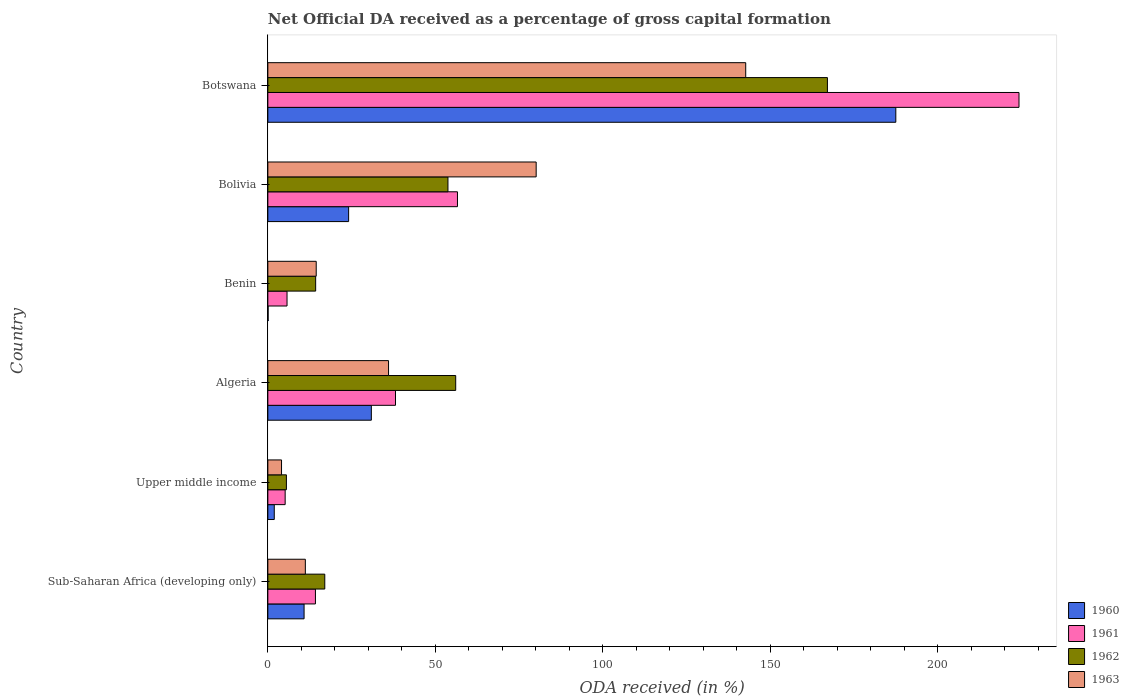How many bars are there on the 3rd tick from the top?
Make the answer very short. 4. How many bars are there on the 2nd tick from the bottom?
Make the answer very short. 4. What is the label of the 4th group of bars from the top?
Give a very brief answer. Algeria. What is the net ODA received in 1960 in Botswana?
Offer a terse response. 187.49. Across all countries, what is the maximum net ODA received in 1962?
Your response must be concise. 167.07. Across all countries, what is the minimum net ODA received in 1961?
Offer a very short reply. 5.17. In which country was the net ODA received in 1961 maximum?
Offer a terse response. Botswana. In which country was the net ODA received in 1960 minimum?
Your answer should be very brief. Benin. What is the total net ODA received in 1963 in the graph?
Provide a short and direct response. 288.55. What is the difference between the net ODA received in 1962 in Sub-Saharan Africa (developing only) and that in Upper middle income?
Provide a succinct answer. 11.45. What is the difference between the net ODA received in 1962 in Benin and the net ODA received in 1960 in Upper middle income?
Give a very brief answer. 12.36. What is the average net ODA received in 1962 per country?
Offer a very short reply. 52.29. What is the difference between the net ODA received in 1960 and net ODA received in 1963 in Sub-Saharan Africa (developing only)?
Ensure brevity in your answer.  -0.38. What is the ratio of the net ODA received in 1962 in Benin to that in Upper middle income?
Provide a short and direct response. 2.58. Is the difference between the net ODA received in 1960 in Algeria and Botswana greater than the difference between the net ODA received in 1963 in Algeria and Botswana?
Your answer should be very brief. No. What is the difference between the highest and the second highest net ODA received in 1963?
Provide a succinct answer. 62.56. What is the difference between the highest and the lowest net ODA received in 1963?
Provide a succinct answer. 138.59. In how many countries, is the net ODA received in 1960 greater than the average net ODA received in 1960 taken over all countries?
Keep it short and to the point. 1. Is the sum of the net ODA received in 1962 in Algeria and Benin greater than the maximum net ODA received in 1963 across all countries?
Make the answer very short. No. Is it the case that in every country, the sum of the net ODA received in 1962 and net ODA received in 1961 is greater than the sum of net ODA received in 1963 and net ODA received in 1960?
Offer a terse response. No. What does the 3rd bar from the bottom in Botswana represents?
Provide a short and direct response. 1962. How many bars are there?
Provide a short and direct response. 24. Are all the bars in the graph horizontal?
Make the answer very short. Yes. How many countries are there in the graph?
Give a very brief answer. 6. Does the graph contain any zero values?
Keep it short and to the point. No. Does the graph contain grids?
Offer a terse response. No. Where does the legend appear in the graph?
Give a very brief answer. Bottom right. How are the legend labels stacked?
Make the answer very short. Vertical. What is the title of the graph?
Offer a very short reply. Net Official DA received as a percentage of gross capital formation. What is the label or title of the X-axis?
Provide a short and direct response. ODA received (in %). What is the ODA received (in %) in 1960 in Sub-Saharan Africa (developing only)?
Give a very brief answer. 10.82. What is the ODA received (in %) in 1961 in Sub-Saharan Africa (developing only)?
Your answer should be compact. 14.21. What is the ODA received (in %) of 1962 in Sub-Saharan Africa (developing only)?
Your answer should be compact. 17. What is the ODA received (in %) in 1963 in Sub-Saharan Africa (developing only)?
Provide a succinct answer. 11.2. What is the ODA received (in %) of 1960 in Upper middle income?
Make the answer very short. 1.92. What is the ODA received (in %) in 1961 in Upper middle income?
Your answer should be very brief. 5.17. What is the ODA received (in %) of 1962 in Upper middle income?
Your answer should be very brief. 5.54. What is the ODA received (in %) in 1963 in Upper middle income?
Provide a succinct answer. 4.09. What is the ODA received (in %) of 1960 in Algeria?
Offer a very short reply. 30.9. What is the ODA received (in %) in 1961 in Algeria?
Provide a short and direct response. 38.11. What is the ODA received (in %) of 1962 in Algeria?
Your answer should be compact. 56.09. What is the ODA received (in %) in 1963 in Algeria?
Ensure brevity in your answer.  36.04. What is the ODA received (in %) of 1960 in Benin?
Your response must be concise. 0.08. What is the ODA received (in %) of 1961 in Benin?
Your response must be concise. 5.73. What is the ODA received (in %) in 1962 in Benin?
Provide a succinct answer. 14.28. What is the ODA received (in %) in 1963 in Benin?
Ensure brevity in your answer.  14.44. What is the ODA received (in %) of 1960 in Bolivia?
Keep it short and to the point. 24.12. What is the ODA received (in %) in 1961 in Bolivia?
Ensure brevity in your answer.  56.62. What is the ODA received (in %) in 1962 in Bolivia?
Provide a succinct answer. 53.77. What is the ODA received (in %) in 1963 in Bolivia?
Give a very brief answer. 80.11. What is the ODA received (in %) of 1960 in Botswana?
Your response must be concise. 187.49. What is the ODA received (in %) of 1961 in Botswana?
Your answer should be compact. 224.27. What is the ODA received (in %) in 1962 in Botswana?
Provide a succinct answer. 167.07. What is the ODA received (in %) of 1963 in Botswana?
Give a very brief answer. 142.68. Across all countries, what is the maximum ODA received (in %) of 1960?
Offer a terse response. 187.49. Across all countries, what is the maximum ODA received (in %) of 1961?
Offer a terse response. 224.27. Across all countries, what is the maximum ODA received (in %) of 1962?
Ensure brevity in your answer.  167.07. Across all countries, what is the maximum ODA received (in %) in 1963?
Ensure brevity in your answer.  142.68. Across all countries, what is the minimum ODA received (in %) of 1960?
Provide a succinct answer. 0.08. Across all countries, what is the minimum ODA received (in %) of 1961?
Give a very brief answer. 5.17. Across all countries, what is the minimum ODA received (in %) in 1962?
Ensure brevity in your answer.  5.54. Across all countries, what is the minimum ODA received (in %) in 1963?
Make the answer very short. 4.09. What is the total ODA received (in %) in 1960 in the graph?
Make the answer very short. 255.32. What is the total ODA received (in %) in 1961 in the graph?
Offer a very short reply. 344.1. What is the total ODA received (in %) of 1962 in the graph?
Your answer should be very brief. 313.75. What is the total ODA received (in %) in 1963 in the graph?
Offer a terse response. 288.55. What is the difference between the ODA received (in %) in 1960 in Sub-Saharan Africa (developing only) and that in Upper middle income?
Offer a very short reply. 8.9. What is the difference between the ODA received (in %) of 1961 in Sub-Saharan Africa (developing only) and that in Upper middle income?
Offer a terse response. 9.04. What is the difference between the ODA received (in %) in 1962 in Sub-Saharan Africa (developing only) and that in Upper middle income?
Your response must be concise. 11.45. What is the difference between the ODA received (in %) in 1963 in Sub-Saharan Africa (developing only) and that in Upper middle income?
Make the answer very short. 7.11. What is the difference between the ODA received (in %) in 1960 in Sub-Saharan Africa (developing only) and that in Algeria?
Offer a terse response. -20.09. What is the difference between the ODA received (in %) of 1961 in Sub-Saharan Africa (developing only) and that in Algeria?
Your answer should be very brief. -23.9. What is the difference between the ODA received (in %) of 1962 in Sub-Saharan Africa (developing only) and that in Algeria?
Offer a terse response. -39.09. What is the difference between the ODA received (in %) of 1963 in Sub-Saharan Africa (developing only) and that in Algeria?
Give a very brief answer. -24.84. What is the difference between the ODA received (in %) in 1960 in Sub-Saharan Africa (developing only) and that in Benin?
Make the answer very short. 10.74. What is the difference between the ODA received (in %) of 1961 in Sub-Saharan Africa (developing only) and that in Benin?
Offer a terse response. 8.48. What is the difference between the ODA received (in %) in 1962 in Sub-Saharan Africa (developing only) and that in Benin?
Offer a very short reply. 2.72. What is the difference between the ODA received (in %) of 1963 in Sub-Saharan Africa (developing only) and that in Benin?
Provide a short and direct response. -3.25. What is the difference between the ODA received (in %) in 1960 in Sub-Saharan Africa (developing only) and that in Bolivia?
Make the answer very short. -13.3. What is the difference between the ODA received (in %) of 1961 in Sub-Saharan Africa (developing only) and that in Bolivia?
Your answer should be very brief. -42.41. What is the difference between the ODA received (in %) of 1962 in Sub-Saharan Africa (developing only) and that in Bolivia?
Keep it short and to the point. -36.78. What is the difference between the ODA received (in %) in 1963 in Sub-Saharan Africa (developing only) and that in Bolivia?
Make the answer very short. -68.92. What is the difference between the ODA received (in %) in 1960 in Sub-Saharan Africa (developing only) and that in Botswana?
Give a very brief answer. -176.67. What is the difference between the ODA received (in %) of 1961 in Sub-Saharan Africa (developing only) and that in Botswana?
Give a very brief answer. -210.06. What is the difference between the ODA received (in %) of 1962 in Sub-Saharan Africa (developing only) and that in Botswana?
Your response must be concise. -150.07. What is the difference between the ODA received (in %) in 1963 in Sub-Saharan Africa (developing only) and that in Botswana?
Offer a terse response. -131.48. What is the difference between the ODA received (in %) in 1960 in Upper middle income and that in Algeria?
Your response must be concise. -28.99. What is the difference between the ODA received (in %) in 1961 in Upper middle income and that in Algeria?
Offer a very short reply. -32.94. What is the difference between the ODA received (in %) of 1962 in Upper middle income and that in Algeria?
Give a very brief answer. -50.54. What is the difference between the ODA received (in %) of 1963 in Upper middle income and that in Algeria?
Your answer should be compact. -31.95. What is the difference between the ODA received (in %) in 1960 in Upper middle income and that in Benin?
Provide a succinct answer. 1.84. What is the difference between the ODA received (in %) of 1961 in Upper middle income and that in Benin?
Provide a succinct answer. -0.56. What is the difference between the ODA received (in %) in 1962 in Upper middle income and that in Benin?
Your response must be concise. -8.73. What is the difference between the ODA received (in %) of 1963 in Upper middle income and that in Benin?
Keep it short and to the point. -10.35. What is the difference between the ODA received (in %) in 1960 in Upper middle income and that in Bolivia?
Ensure brevity in your answer.  -22.2. What is the difference between the ODA received (in %) of 1961 in Upper middle income and that in Bolivia?
Your answer should be very brief. -51.45. What is the difference between the ODA received (in %) of 1962 in Upper middle income and that in Bolivia?
Your answer should be very brief. -48.23. What is the difference between the ODA received (in %) in 1963 in Upper middle income and that in Bolivia?
Make the answer very short. -76.03. What is the difference between the ODA received (in %) of 1960 in Upper middle income and that in Botswana?
Offer a terse response. -185.57. What is the difference between the ODA received (in %) of 1961 in Upper middle income and that in Botswana?
Your response must be concise. -219.1. What is the difference between the ODA received (in %) in 1962 in Upper middle income and that in Botswana?
Offer a very short reply. -161.53. What is the difference between the ODA received (in %) in 1963 in Upper middle income and that in Botswana?
Your response must be concise. -138.59. What is the difference between the ODA received (in %) of 1960 in Algeria and that in Benin?
Keep it short and to the point. 30.82. What is the difference between the ODA received (in %) in 1961 in Algeria and that in Benin?
Offer a very short reply. 32.39. What is the difference between the ODA received (in %) in 1962 in Algeria and that in Benin?
Make the answer very short. 41.81. What is the difference between the ODA received (in %) of 1963 in Algeria and that in Benin?
Offer a very short reply. 21.6. What is the difference between the ODA received (in %) of 1960 in Algeria and that in Bolivia?
Your response must be concise. 6.78. What is the difference between the ODA received (in %) in 1961 in Algeria and that in Bolivia?
Offer a very short reply. -18.5. What is the difference between the ODA received (in %) in 1962 in Algeria and that in Bolivia?
Your answer should be very brief. 2.31. What is the difference between the ODA received (in %) of 1963 in Algeria and that in Bolivia?
Provide a succinct answer. -44.08. What is the difference between the ODA received (in %) of 1960 in Algeria and that in Botswana?
Offer a very short reply. -156.58. What is the difference between the ODA received (in %) of 1961 in Algeria and that in Botswana?
Your response must be concise. -186.15. What is the difference between the ODA received (in %) in 1962 in Algeria and that in Botswana?
Keep it short and to the point. -110.98. What is the difference between the ODA received (in %) in 1963 in Algeria and that in Botswana?
Keep it short and to the point. -106.64. What is the difference between the ODA received (in %) in 1960 in Benin and that in Bolivia?
Make the answer very short. -24.04. What is the difference between the ODA received (in %) of 1961 in Benin and that in Bolivia?
Keep it short and to the point. -50.89. What is the difference between the ODA received (in %) of 1962 in Benin and that in Bolivia?
Your answer should be compact. -39.5. What is the difference between the ODA received (in %) of 1963 in Benin and that in Bolivia?
Ensure brevity in your answer.  -65.67. What is the difference between the ODA received (in %) in 1960 in Benin and that in Botswana?
Offer a terse response. -187.41. What is the difference between the ODA received (in %) of 1961 in Benin and that in Botswana?
Provide a succinct answer. -218.54. What is the difference between the ODA received (in %) in 1962 in Benin and that in Botswana?
Make the answer very short. -152.79. What is the difference between the ODA received (in %) of 1963 in Benin and that in Botswana?
Your answer should be very brief. -128.24. What is the difference between the ODA received (in %) in 1960 in Bolivia and that in Botswana?
Your answer should be compact. -163.37. What is the difference between the ODA received (in %) in 1961 in Bolivia and that in Botswana?
Keep it short and to the point. -167.65. What is the difference between the ODA received (in %) of 1962 in Bolivia and that in Botswana?
Your response must be concise. -113.3. What is the difference between the ODA received (in %) of 1963 in Bolivia and that in Botswana?
Provide a short and direct response. -62.56. What is the difference between the ODA received (in %) of 1960 in Sub-Saharan Africa (developing only) and the ODA received (in %) of 1961 in Upper middle income?
Ensure brevity in your answer.  5.65. What is the difference between the ODA received (in %) of 1960 in Sub-Saharan Africa (developing only) and the ODA received (in %) of 1962 in Upper middle income?
Offer a very short reply. 5.27. What is the difference between the ODA received (in %) in 1960 in Sub-Saharan Africa (developing only) and the ODA received (in %) in 1963 in Upper middle income?
Ensure brevity in your answer.  6.73. What is the difference between the ODA received (in %) of 1961 in Sub-Saharan Africa (developing only) and the ODA received (in %) of 1962 in Upper middle income?
Your answer should be compact. 8.67. What is the difference between the ODA received (in %) in 1961 in Sub-Saharan Africa (developing only) and the ODA received (in %) in 1963 in Upper middle income?
Provide a succinct answer. 10.12. What is the difference between the ODA received (in %) in 1962 in Sub-Saharan Africa (developing only) and the ODA received (in %) in 1963 in Upper middle income?
Give a very brief answer. 12.91. What is the difference between the ODA received (in %) in 1960 in Sub-Saharan Africa (developing only) and the ODA received (in %) in 1961 in Algeria?
Offer a very short reply. -27.3. What is the difference between the ODA received (in %) in 1960 in Sub-Saharan Africa (developing only) and the ODA received (in %) in 1962 in Algeria?
Make the answer very short. -45.27. What is the difference between the ODA received (in %) of 1960 in Sub-Saharan Africa (developing only) and the ODA received (in %) of 1963 in Algeria?
Your answer should be compact. -25.22. What is the difference between the ODA received (in %) in 1961 in Sub-Saharan Africa (developing only) and the ODA received (in %) in 1962 in Algeria?
Ensure brevity in your answer.  -41.88. What is the difference between the ODA received (in %) in 1961 in Sub-Saharan Africa (developing only) and the ODA received (in %) in 1963 in Algeria?
Your answer should be very brief. -21.83. What is the difference between the ODA received (in %) of 1962 in Sub-Saharan Africa (developing only) and the ODA received (in %) of 1963 in Algeria?
Provide a succinct answer. -19.04. What is the difference between the ODA received (in %) in 1960 in Sub-Saharan Africa (developing only) and the ODA received (in %) in 1961 in Benin?
Keep it short and to the point. 5.09. What is the difference between the ODA received (in %) in 1960 in Sub-Saharan Africa (developing only) and the ODA received (in %) in 1962 in Benin?
Offer a very short reply. -3.46. What is the difference between the ODA received (in %) in 1960 in Sub-Saharan Africa (developing only) and the ODA received (in %) in 1963 in Benin?
Provide a succinct answer. -3.62. What is the difference between the ODA received (in %) in 1961 in Sub-Saharan Africa (developing only) and the ODA received (in %) in 1962 in Benin?
Offer a very short reply. -0.07. What is the difference between the ODA received (in %) of 1961 in Sub-Saharan Africa (developing only) and the ODA received (in %) of 1963 in Benin?
Give a very brief answer. -0.23. What is the difference between the ODA received (in %) in 1962 in Sub-Saharan Africa (developing only) and the ODA received (in %) in 1963 in Benin?
Give a very brief answer. 2.56. What is the difference between the ODA received (in %) of 1960 in Sub-Saharan Africa (developing only) and the ODA received (in %) of 1961 in Bolivia?
Ensure brevity in your answer.  -45.8. What is the difference between the ODA received (in %) in 1960 in Sub-Saharan Africa (developing only) and the ODA received (in %) in 1962 in Bolivia?
Offer a very short reply. -42.96. What is the difference between the ODA received (in %) of 1960 in Sub-Saharan Africa (developing only) and the ODA received (in %) of 1963 in Bolivia?
Ensure brevity in your answer.  -69.3. What is the difference between the ODA received (in %) of 1961 in Sub-Saharan Africa (developing only) and the ODA received (in %) of 1962 in Bolivia?
Provide a short and direct response. -39.56. What is the difference between the ODA received (in %) in 1961 in Sub-Saharan Africa (developing only) and the ODA received (in %) in 1963 in Bolivia?
Provide a short and direct response. -65.91. What is the difference between the ODA received (in %) in 1962 in Sub-Saharan Africa (developing only) and the ODA received (in %) in 1963 in Bolivia?
Make the answer very short. -63.12. What is the difference between the ODA received (in %) of 1960 in Sub-Saharan Africa (developing only) and the ODA received (in %) of 1961 in Botswana?
Offer a terse response. -213.45. What is the difference between the ODA received (in %) of 1960 in Sub-Saharan Africa (developing only) and the ODA received (in %) of 1962 in Botswana?
Your answer should be compact. -156.25. What is the difference between the ODA received (in %) of 1960 in Sub-Saharan Africa (developing only) and the ODA received (in %) of 1963 in Botswana?
Keep it short and to the point. -131.86. What is the difference between the ODA received (in %) in 1961 in Sub-Saharan Africa (developing only) and the ODA received (in %) in 1962 in Botswana?
Keep it short and to the point. -152.86. What is the difference between the ODA received (in %) of 1961 in Sub-Saharan Africa (developing only) and the ODA received (in %) of 1963 in Botswana?
Offer a very short reply. -128.47. What is the difference between the ODA received (in %) of 1962 in Sub-Saharan Africa (developing only) and the ODA received (in %) of 1963 in Botswana?
Offer a terse response. -125.68. What is the difference between the ODA received (in %) of 1960 in Upper middle income and the ODA received (in %) of 1961 in Algeria?
Give a very brief answer. -36.2. What is the difference between the ODA received (in %) of 1960 in Upper middle income and the ODA received (in %) of 1962 in Algeria?
Provide a succinct answer. -54.17. What is the difference between the ODA received (in %) in 1960 in Upper middle income and the ODA received (in %) in 1963 in Algeria?
Offer a very short reply. -34.12. What is the difference between the ODA received (in %) of 1961 in Upper middle income and the ODA received (in %) of 1962 in Algeria?
Make the answer very short. -50.92. What is the difference between the ODA received (in %) of 1961 in Upper middle income and the ODA received (in %) of 1963 in Algeria?
Ensure brevity in your answer.  -30.87. What is the difference between the ODA received (in %) in 1962 in Upper middle income and the ODA received (in %) in 1963 in Algeria?
Ensure brevity in your answer.  -30.49. What is the difference between the ODA received (in %) in 1960 in Upper middle income and the ODA received (in %) in 1961 in Benin?
Keep it short and to the point. -3.81. What is the difference between the ODA received (in %) of 1960 in Upper middle income and the ODA received (in %) of 1962 in Benin?
Your response must be concise. -12.36. What is the difference between the ODA received (in %) of 1960 in Upper middle income and the ODA received (in %) of 1963 in Benin?
Keep it short and to the point. -12.53. What is the difference between the ODA received (in %) in 1961 in Upper middle income and the ODA received (in %) in 1962 in Benin?
Provide a succinct answer. -9.11. What is the difference between the ODA received (in %) of 1961 in Upper middle income and the ODA received (in %) of 1963 in Benin?
Your response must be concise. -9.27. What is the difference between the ODA received (in %) in 1962 in Upper middle income and the ODA received (in %) in 1963 in Benin?
Give a very brief answer. -8.9. What is the difference between the ODA received (in %) of 1960 in Upper middle income and the ODA received (in %) of 1961 in Bolivia?
Provide a short and direct response. -54.7. What is the difference between the ODA received (in %) of 1960 in Upper middle income and the ODA received (in %) of 1962 in Bolivia?
Provide a succinct answer. -51.86. What is the difference between the ODA received (in %) in 1960 in Upper middle income and the ODA received (in %) in 1963 in Bolivia?
Give a very brief answer. -78.2. What is the difference between the ODA received (in %) in 1961 in Upper middle income and the ODA received (in %) in 1962 in Bolivia?
Offer a terse response. -48.6. What is the difference between the ODA received (in %) in 1961 in Upper middle income and the ODA received (in %) in 1963 in Bolivia?
Provide a succinct answer. -74.94. What is the difference between the ODA received (in %) in 1962 in Upper middle income and the ODA received (in %) in 1963 in Bolivia?
Your answer should be very brief. -74.57. What is the difference between the ODA received (in %) of 1960 in Upper middle income and the ODA received (in %) of 1961 in Botswana?
Ensure brevity in your answer.  -222.35. What is the difference between the ODA received (in %) of 1960 in Upper middle income and the ODA received (in %) of 1962 in Botswana?
Your response must be concise. -165.15. What is the difference between the ODA received (in %) in 1960 in Upper middle income and the ODA received (in %) in 1963 in Botswana?
Give a very brief answer. -140.76. What is the difference between the ODA received (in %) of 1961 in Upper middle income and the ODA received (in %) of 1962 in Botswana?
Provide a short and direct response. -161.9. What is the difference between the ODA received (in %) of 1961 in Upper middle income and the ODA received (in %) of 1963 in Botswana?
Your answer should be compact. -137.51. What is the difference between the ODA received (in %) of 1962 in Upper middle income and the ODA received (in %) of 1963 in Botswana?
Ensure brevity in your answer.  -137.13. What is the difference between the ODA received (in %) in 1960 in Algeria and the ODA received (in %) in 1961 in Benin?
Provide a short and direct response. 25.17. What is the difference between the ODA received (in %) in 1960 in Algeria and the ODA received (in %) in 1962 in Benin?
Provide a short and direct response. 16.62. What is the difference between the ODA received (in %) of 1960 in Algeria and the ODA received (in %) of 1963 in Benin?
Ensure brevity in your answer.  16.46. What is the difference between the ODA received (in %) in 1961 in Algeria and the ODA received (in %) in 1962 in Benin?
Your answer should be compact. 23.84. What is the difference between the ODA received (in %) in 1961 in Algeria and the ODA received (in %) in 1963 in Benin?
Provide a short and direct response. 23.67. What is the difference between the ODA received (in %) in 1962 in Algeria and the ODA received (in %) in 1963 in Benin?
Your response must be concise. 41.65. What is the difference between the ODA received (in %) of 1960 in Algeria and the ODA received (in %) of 1961 in Bolivia?
Offer a very short reply. -25.71. What is the difference between the ODA received (in %) of 1960 in Algeria and the ODA received (in %) of 1962 in Bolivia?
Give a very brief answer. -22.87. What is the difference between the ODA received (in %) of 1960 in Algeria and the ODA received (in %) of 1963 in Bolivia?
Your answer should be very brief. -49.21. What is the difference between the ODA received (in %) of 1961 in Algeria and the ODA received (in %) of 1962 in Bolivia?
Your response must be concise. -15.66. What is the difference between the ODA received (in %) of 1961 in Algeria and the ODA received (in %) of 1963 in Bolivia?
Your answer should be very brief. -42. What is the difference between the ODA received (in %) of 1962 in Algeria and the ODA received (in %) of 1963 in Bolivia?
Ensure brevity in your answer.  -24.03. What is the difference between the ODA received (in %) of 1960 in Algeria and the ODA received (in %) of 1961 in Botswana?
Offer a very short reply. -193.36. What is the difference between the ODA received (in %) of 1960 in Algeria and the ODA received (in %) of 1962 in Botswana?
Your answer should be very brief. -136.17. What is the difference between the ODA received (in %) in 1960 in Algeria and the ODA received (in %) in 1963 in Botswana?
Your response must be concise. -111.78. What is the difference between the ODA received (in %) of 1961 in Algeria and the ODA received (in %) of 1962 in Botswana?
Your answer should be very brief. -128.96. What is the difference between the ODA received (in %) of 1961 in Algeria and the ODA received (in %) of 1963 in Botswana?
Ensure brevity in your answer.  -104.56. What is the difference between the ODA received (in %) of 1962 in Algeria and the ODA received (in %) of 1963 in Botswana?
Keep it short and to the point. -86.59. What is the difference between the ODA received (in %) of 1960 in Benin and the ODA received (in %) of 1961 in Bolivia?
Your answer should be very brief. -56.54. What is the difference between the ODA received (in %) of 1960 in Benin and the ODA received (in %) of 1962 in Bolivia?
Give a very brief answer. -53.7. What is the difference between the ODA received (in %) of 1960 in Benin and the ODA received (in %) of 1963 in Bolivia?
Offer a terse response. -80.04. What is the difference between the ODA received (in %) of 1961 in Benin and the ODA received (in %) of 1962 in Bolivia?
Make the answer very short. -48.05. What is the difference between the ODA received (in %) in 1961 in Benin and the ODA received (in %) in 1963 in Bolivia?
Offer a terse response. -74.39. What is the difference between the ODA received (in %) in 1962 in Benin and the ODA received (in %) in 1963 in Bolivia?
Offer a terse response. -65.84. What is the difference between the ODA received (in %) of 1960 in Benin and the ODA received (in %) of 1961 in Botswana?
Provide a succinct answer. -224.19. What is the difference between the ODA received (in %) in 1960 in Benin and the ODA received (in %) in 1962 in Botswana?
Offer a very short reply. -166.99. What is the difference between the ODA received (in %) of 1960 in Benin and the ODA received (in %) of 1963 in Botswana?
Keep it short and to the point. -142.6. What is the difference between the ODA received (in %) of 1961 in Benin and the ODA received (in %) of 1962 in Botswana?
Your answer should be very brief. -161.34. What is the difference between the ODA received (in %) of 1961 in Benin and the ODA received (in %) of 1963 in Botswana?
Offer a terse response. -136.95. What is the difference between the ODA received (in %) of 1962 in Benin and the ODA received (in %) of 1963 in Botswana?
Make the answer very short. -128.4. What is the difference between the ODA received (in %) in 1960 in Bolivia and the ODA received (in %) in 1961 in Botswana?
Your answer should be compact. -200.15. What is the difference between the ODA received (in %) in 1960 in Bolivia and the ODA received (in %) in 1962 in Botswana?
Offer a terse response. -142.95. What is the difference between the ODA received (in %) of 1960 in Bolivia and the ODA received (in %) of 1963 in Botswana?
Provide a short and direct response. -118.56. What is the difference between the ODA received (in %) in 1961 in Bolivia and the ODA received (in %) in 1962 in Botswana?
Your answer should be compact. -110.45. What is the difference between the ODA received (in %) in 1961 in Bolivia and the ODA received (in %) in 1963 in Botswana?
Provide a short and direct response. -86.06. What is the difference between the ODA received (in %) of 1962 in Bolivia and the ODA received (in %) of 1963 in Botswana?
Give a very brief answer. -88.9. What is the average ODA received (in %) of 1960 per country?
Offer a very short reply. 42.55. What is the average ODA received (in %) of 1961 per country?
Ensure brevity in your answer.  57.35. What is the average ODA received (in %) in 1962 per country?
Ensure brevity in your answer.  52.29. What is the average ODA received (in %) of 1963 per country?
Ensure brevity in your answer.  48.09. What is the difference between the ODA received (in %) in 1960 and ODA received (in %) in 1961 in Sub-Saharan Africa (developing only)?
Your response must be concise. -3.39. What is the difference between the ODA received (in %) of 1960 and ODA received (in %) of 1962 in Sub-Saharan Africa (developing only)?
Ensure brevity in your answer.  -6.18. What is the difference between the ODA received (in %) in 1960 and ODA received (in %) in 1963 in Sub-Saharan Africa (developing only)?
Make the answer very short. -0.38. What is the difference between the ODA received (in %) of 1961 and ODA received (in %) of 1962 in Sub-Saharan Africa (developing only)?
Make the answer very short. -2.79. What is the difference between the ODA received (in %) in 1961 and ODA received (in %) in 1963 in Sub-Saharan Africa (developing only)?
Make the answer very short. 3.01. What is the difference between the ODA received (in %) in 1962 and ODA received (in %) in 1963 in Sub-Saharan Africa (developing only)?
Offer a very short reply. 5.8. What is the difference between the ODA received (in %) of 1960 and ODA received (in %) of 1961 in Upper middle income?
Offer a terse response. -3.25. What is the difference between the ODA received (in %) of 1960 and ODA received (in %) of 1962 in Upper middle income?
Provide a succinct answer. -3.63. What is the difference between the ODA received (in %) of 1960 and ODA received (in %) of 1963 in Upper middle income?
Ensure brevity in your answer.  -2.17. What is the difference between the ODA received (in %) of 1961 and ODA received (in %) of 1962 in Upper middle income?
Your answer should be very brief. -0.37. What is the difference between the ODA received (in %) of 1961 and ODA received (in %) of 1963 in Upper middle income?
Keep it short and to the point. 1.08. What is the difference between the ODA received (in %) in 1962 and ODA received (in %) in 1963 in Upper middle income?
Keep it short and to the point. 1.46. What is the difference between the ODA received (in %) in 1960 and ODA received (in %) in 1961 in Algeria?
Your answer should be compact. -7.21. What is the difference between the ODA received (in %) of 1960 and ODA received (in %) of 1962 in Algeria?
Your answer should be compact. -25.19. What is the difference between the ODA received (in %) in 1960 and ODA received (in %) in 1963 in Algeria?
Provide a succinct answer. -5.14. What is the difference between the ODA received (in %) of 1961 and ODA received (in %) of 1962 in Algeria?
Ensure brevity in your answer.  -17.98. What is the difference between the ODA received (in %) in 1961 and ODA received (in %) in 1963 in Algeria?
Your response must be concise. 2.08. What is the difference between the ODA received (in %) in 1962 and ODA received (in %) in 1963 in Algeria?
Provide a succinct answer. 20.05. What is the difference between the ODA received (in %) in 1960 and ODA received (in %) in 1961 in Benin?
Give a very brief answer. -5.65. What is the difference between the ODA received (in %) in 1960 and ODA received (in %) in 1962 in Benin?
Keep it short and to the point. -14.2. What is the difference between the ODA received (in %) of 1960 and ODA received (in %) of 1963 in Benin?
Your answer should be very brief. -14.36. What is the difference between the ODA received (in %) in 1961 and ODA received (in %) in 1962 in Benin?
Your response must be concise. -8.55. What is the difference between the ODA received (in %) of 1961 and ODA received (in %) of 1963 in Benin?
Offer a very short reply. -8.71. What is the difference between the ODA received (in %) in 1962 and ODA received (in %) in 1963 in Benin?
Keep it short and to the point. -0.16. What is the difference between the ODA received (in %) of 1960 and ODA received (in %) of 1961 in Bolivia?
Your answer should be very brief. -32.5. What is the difference between the ODA received (in %) in 1960 and ODA received (in %) in 1962 in Bolivia?
Your response must be concise. -29.66. What is the difference between the ODA received (in %) in 1960 and ODA received (in %) in 1963 in Bolivia?
Your answer should be compact. -56. What is the difference between the ODA received (in %) of 1961 and ODA received (in %) of 1962 in Bolivia?
Offer a terse response. 2.84. What is the difference between the ODA received (in %) in 1961 and ODA received (in %) in 1963 in Bolivia?
Offer a very short reply. -23.5. What is the difference between the ODA received (in %) in 1962 and ODA received (in %) in 1963 in Bolivia?
Give a very brief answer. -26.34. What is the difference between the ODA received (in %) in 1960 and ODA received (in %) in 1961 in Botswana?
Make the answer very short. -36.78. What is the difference between the ODA received (in %) in 1960 and ODA received (in %) in 1962 in Botswana?
Make the answer very short. 20.42. What is the difference between the ODA received (in %) of 1960 and ODA received (in %) of 1963 in Botswana?
Your answer should be compact. 44.81. What is the difference between the ODA received (in %) of 1961 and ODA received (in %) of 1962 in Botswana?
Your answer should be compact. 57.2. What is the difference between the ODA received (in %) in 1961 and ODA received (in %) in 1963 in Botswana?
Your answer should be compact. 81.59. What is the difference between the ODA received (in %) in 1962 and ODA received (in %) in 1963 in Botswana?
Offer a terse response. 24.39. What is the ratio of the ODA received (in %) of 1960 in Sub-Saharan Africa (developing only) to that in Upper middle income?
Provide a short and direct response. 5.65. What is the ratio of the ODA received (in %) of 1961 in Sub-Saharan Africa (developing only) to that in Upper middle income?
Provide a succinct answer. 2.75. What is the ratio of the ODA received (in %) in 1962 in Sub-Saharan Africa (developing only) to that in Upper middle income?
Provide a succinct answer. 3.07. What is the ratio of the ODA received (in %) of 1963 in Sub-Saharan Africa (developing only) to that in Upper middle income?
Your answer should be compact. 2.74. What is the ratio of the ODA received (in %) of 1961 in Sub-Saharan Africa (developing only) to that in Algeria?
Provide a short and direct response. 0.37. What is the ratio of the ODA received (in %) of 1962 in Sub-Saharan Africa (developing only) to that in Algeria?
Offer a terse response. 0.3. What is the ratio of the ODA received (in %) of 1963 in Sub-Saharan Africa (developing only) to that in Algeria?
Keep it short and to the point. 0.31. What is the ratio of the ODA received (in %) of 1960 in Sub-Saharan Africa (developing only) to that in Benin?
Provide a succinct answer. 139.77. What is the ratio of the ODA received (in %) in 1961 in Sub-Saharan Africa (developing only) to that in Benin?
Your answer should be compact. 2.48. What is the ratio of the ODA received (in %) of 1962 in Sub-Saharan Africa (developing only) to that in Benin?
Ensure brevity in your answer.  1.19. What is the ratio of the ODA received (in %) of 1963 in Sub-Saharan Africa (developing only) to that in Benin?
Your answer should be very brief. 0.78. What is the ratio of the ODA received (in %) in 1960 in Sub-Saharan Africa (developing only) to that in Bolivia?
Your response must be concise. 0.45. What is the ratio of the ODA received (in %) of 1961 in Sub-Saharan Africa (developing only) to that in Bolivia?
Provide a succinct answer. 0.25. What is the ratio of the ODA received (in %) of 1962 in Sub-Saharan Africa (developing only) to that in Bolivia?
Provide a succinct answer. 0.32. What is the ratio of the ODA received (in %) in 1963 in Sub-Saharan Africa (developing only) to that in Bolivia?
Your answer should be very brief. 0.14. What is the ratio of the ODA received (in %) of 1960 in Sub-Saharan Africa (developing only) to that in Botswana?
Make the answer very short. 0.06. What is the ratio of the ODA received (in %) of 1961 in Sub-Saharan Africa (developing only) to that in Botswana?
Make the answer very short. 0.06. What is the ratio of the ODA received (in %) of 1962 in Sub-Saharan Africa (developing only) to that in Botswana?
Give a very brief answer. 0.1. What is the ratio of the ODA received (in %) of 1963 in Sub-Saharan Africa (developing only) to that in Botswana?
Your response must be concise. 0.08. What is the ratio of the ODA received (in %) in 1960 in Upper middle income to that in Algeria?
Give a very brief answer. 0.06. What is the ratio of the ODA received (in %) in 1961 in Upper middle income to that in Algeria?
Offer a terse response. 0.14. What is the ratio of the ODA received (in %) in 1962 in Upper middle income to that in Algeria?
Offer a very short reply. 0.1. What is the ratio of the ODA received (in %) of 1963 in Upper middle income to that in Algeria?
Offer a very short reply. 0.11. What is the ratio of the ODA received (in %) of 1960 in Upper middle income to that in Benin?
Your answer should be compact. 24.75. What is the ratio of the ODA received (in %) of 1961 in Upper middle income to that in Benin?
Ensure brevity in your answer.  0.9. What is the ratio of the ODA received (in %) of 1962 in Upper middle income to that in Benin?
Provide a succinct answer. 0.39. What is the ratio of the ODA received (in %) in 1963 in Upper middle income to that in Benin?
Keep it short and to the point. 0.28. What is the ratio of the ODA received (in %) in 1960 in Upper middle income to that in Bolivia?
Provide a succinct answer. 0.08. What is the ratio of the ODA received (in %) of 1961 in Upper middle income to that in Bolivia?
Make the answer very short. 0.09. What is the ratio of the ODA received (in %) of 1962 in Upper middle income to that in Bolivia?
Your response must be concise. 0.1. What is the ratio of the ODA received (in %) in 1963 in Upper middle income to that in Bolivia?
Your answer should be compact. 0.05. What is the ratio of the ODA received (in %) of 1960 in Upper middle income to that in Botswana?
Provide a succinct answer. 0.01. What is the ratio of the ODA received (in %) of 1961 in Upper middle income to that in Botswana?
Ensure brevity in your answer.  0.02. What is the ratio of the ODA received (in %) of 1962 in Upper middle income to that in Botswana?
Keep it short and to the point. 0.03. What is the ratio of the ODA received (in %) of 1963 in Upper middle income to that in Botswana?
Provide a succinct answer. 0.03. What is the ratio of the ODA received (in %) of 1960 in Algeria to that in Benin?
Your answer should be compact. 399.3. What is the ratio of the ODA received (in %) in 1961 in Algeria to that in Benin?
Provide a short and direct response. 6.65. What is the ratio of the ODA received (in %) of 1962 in Algeria to that in Benin?
Make the answer very short. 3.93. What is the ratio of the ODA received (in %) in 1963 in Algeria to that in Benin?
Ensure brevity in your answer.  2.5. What is the ratio of the ODA received (in %) in 1960 in Algeria to that in Bolivia?
Give a very brief answer. 1.28. What is the ratio of the ODA received (in %) in 1961 in Algeria to that in Bolivia?
Your answer should be very brief. 0.67. What is the ratio of the ODA received (in %) of 1962 in Algeria to that in Bolivia?
Your response must be concise. 1.04. What is the ratio of the ODA received (in %) in 1963 in Algeria to that in Bolivia?
Give a very brief answer. 0.45. What is the ratio of the ODA received (in %) in 1960 in Algeria to that in Botswana?
Offer a very short reply. 0.16. What is the ratio of the ODA received (in %) of 1961 in Algeria to that in Botswana?
Keep it short and to the point. 0.17. What is the ratio of the ODA received (in %) of 1962 in Algeria to that in Botswana?
Offer a terse response. 0.34. What is the ratio of the ODA received (in %) of 1963 in Algeria to that in Botswana?
Keep it short and to the point. 0.25. What is the ratio of the ODA received (in %) of 1960 in Benin to that in Bolivia?
Provide a short and direct response. 0. What is the ratio of the ODA received (in %) in 1961 in Benin to that in Bolivia?
Your answer should be very brief. 0.1. What is the ratio of the ODA received (in %) of 1962 in Benin to that in Bolivia?
Your response must be concise. 0.27. What is the ratio of the ODA received (in %) in 1963 in Benin to that in Bolivia?
Keep it short and to the point. 0.18. What is the ratio of the ODA received (in %) of 1961 in Benin to that in Botswana?
Provide a succinct answer. 0.03. What is the ratio of the ODA received (in %) of 1962 in Benin to that in Botswana?
Provide a short and direct response. 0.09. What is the ratio of the ODA received (in %) of 1963 in Benin to that in Botswana?
Provide a succinct answer. 0.1. What is the ratio of the ODA received (in %) of 1960 in Bolivia to that in Botswana?
Offer a very short reply. 0.13. What is the ratio of the ODA received (in %) in 1961 in Bolivia to that in Botswana?
Provide a short and direct response. 0.25. What is the ratio of the ODA received (in %) of 1962 in Bolivia to that in Botswana?
Provide a succinct answer. 0.32. What is the ratio of the ODA received (in %) in 1963 in Bolivia to that in Botswana?
Make the answer very short. 0.56. What is the difference between the highest and the second highest ODA received (in %) of 1960?
Provide a succinct answer. 156.58. What is the difference between the highest and the second highest ODA received (in %) of 1961?
Provide a short and direct response. 167.65. What is the difference between the highest and the second highest ODA received (in %) in 1962?
Offer a terse response. 110.98. What is the difference between the highest and the second highest ODA received (in %) in 1963?
Your answer should be compact. 62.56. What is the difference between the highest and the lowest ODA received (in %) in 1960?
Offer a terse response. 187.41. What is the difference between the highest and the lowest ODA received (in %) in 1961?
Give a very brief answer. 219.1. What is the difference between the highest and the lowest ODA received (in %) of 1962?
Ensure brevity in your answer.  161.53. What is the difference between the highest and the lowest ODA received (in %) in 1963?
Your response must be concise. 138.59. 